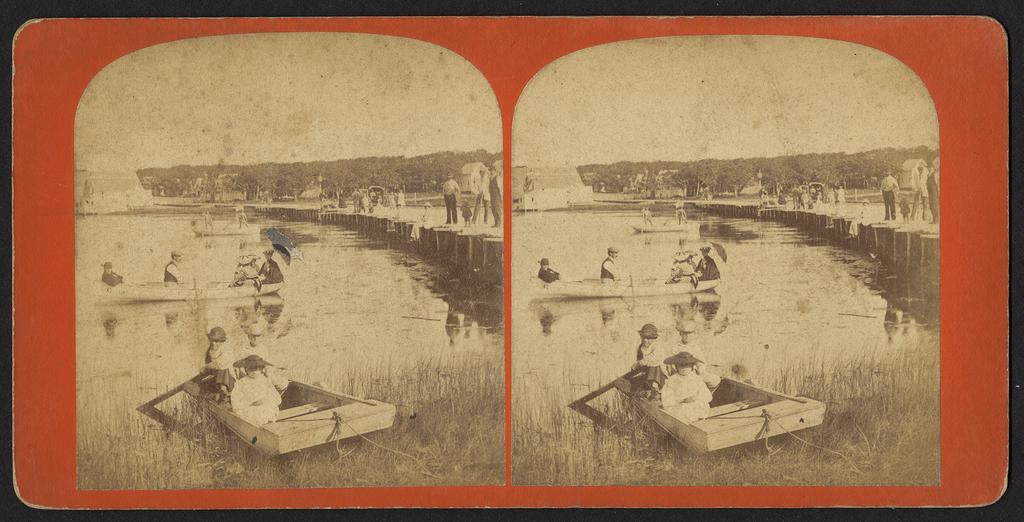What are the people doing in the image? The people are in boats in the image. What structure can be seen in the image? There is a bridge in the image. Are there any people on the bridge? Yes, there are people on the bridge. What type of vegetation is visible in the image? There are plants and grass visible in the image. What type of skirt is being used to support the vessel in the image? There is no skirt or vessel present in the image. What type of support is being provided by the plants in the image? The plants in the image are not providing any support; they are simply part of the natural scenery. 